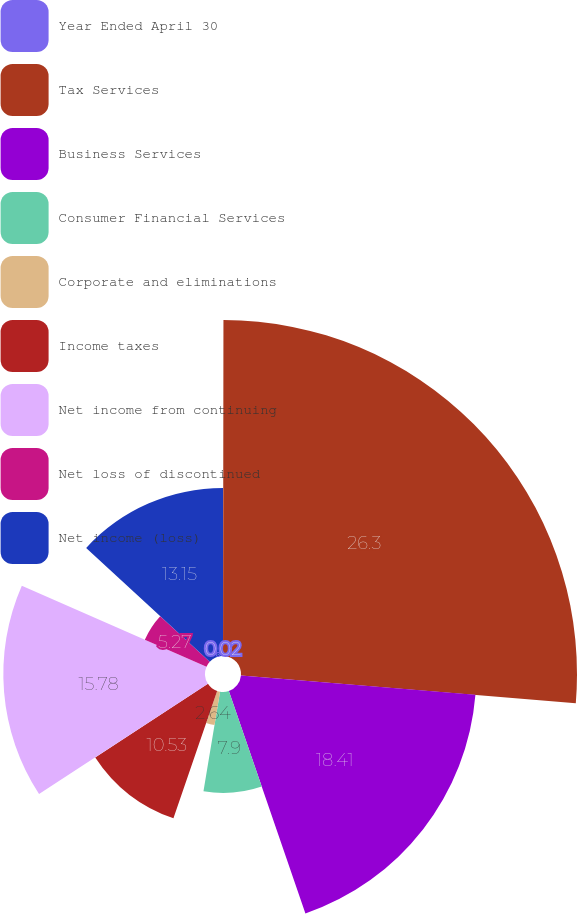Convert chart to OTSL. <chart><loc_0><loc_0><loc_500><loc_500><pie_chart><fcel>Year Ended April 30<fcel>Tax Services<fcel>Business Services<fcel>Consumer Financial Services<fcel>Corporate and eliminations<fcel>Income taxes<fcel>Net income from continuing<fcel>Net loss of discontinued<fcel>Net income (loss)<nl><fcel>0.02%<fcel>26.29%<fcel>18.41%<fcel>7.9%<fcel>2.64%<fcel>10.53%<fcel>15.78%<fcel>5.27%<fcel>13.15%<nl></chart> 